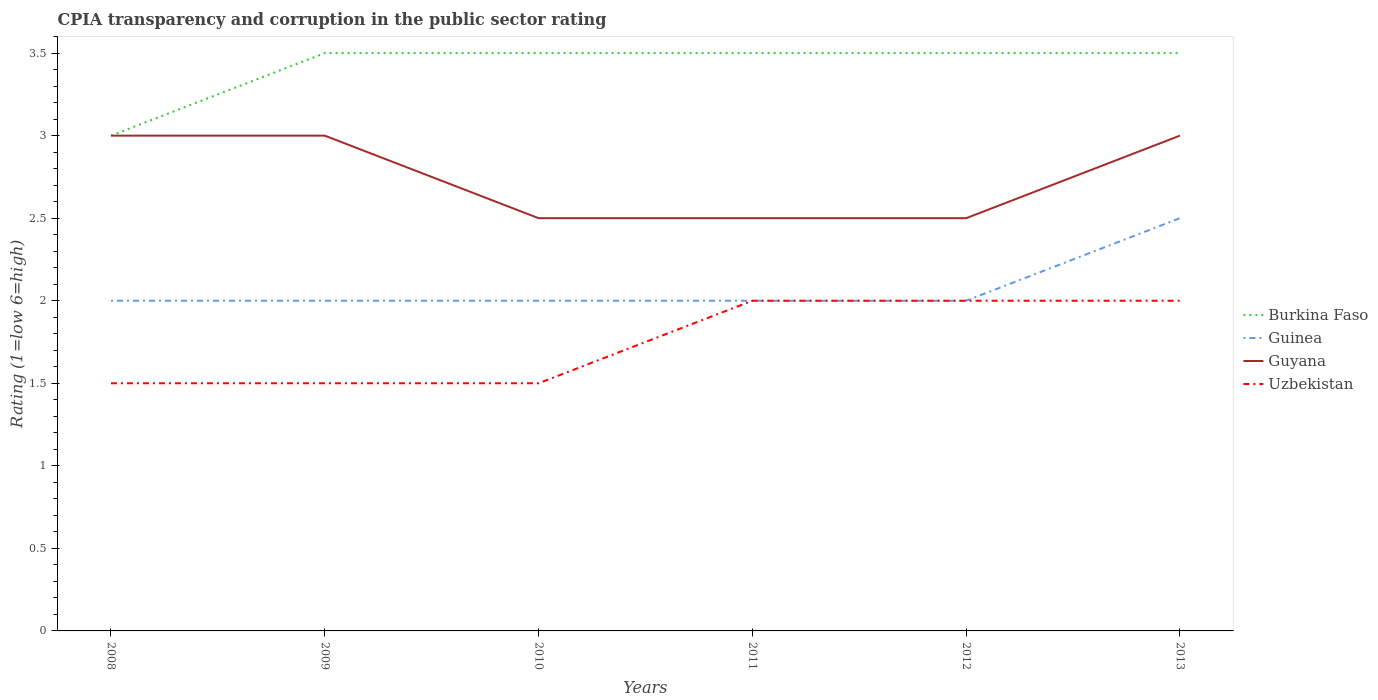Does the line corresponding to Guyana intersect with the line corresponding to Uzbekistan?
Offer a terse response. No. Is the number of lines equal to the number of legend labels?
Offer a very short reply. Yes. In which year was the CPIA rating in Uzbekistan maximum?
Provide a succinct answer. 2008. What is the total CPIA rating in Guinea in the graph?
Your response must be concise. -0.5. Is the CPIA rating in Burkina Faso strictly greater than the CPIA rating in Uzbekistan over the years?
Provide a succinct answer. No. What is the difference between two consecutive major ticks on the Y-axis?
Your answer should be compact. 0.5. Does the graph contain any zero values?
Offer a terse response. No. Does the graph contain grids?
Provide a succinct answer. No. Where does the legend appear in the graph?
Your answer should be very brief. Center right. How are the legend labels stacked?
Provide a succinct answer. Vertical. What is the title of the graph?
Your answer should be very brief. CPIA transparency and corruption in the public sector rating. What is the label or title of the X-axis?
Ensure brevity in your answer.  Years. What is the Rating (1=low 6=high) in Guinea in 2008?
Your response must be concise. 2. What is the Rating (1=low 6=high) of Guyana in 2008?
Your answer should be very brief. 3. What is the Rating (1=low 6=high) in Burkina Faso in 2009?
Your answer should be compact. 3.5. What is the Rating (1=low 6=high) in Guinea in 2009?
Provide a short and direct response. 2. What is the Rating (1=low 6=high) of Uzbekistan in 2009?
Provide a succinct answer. 1.5. What is the Rating (1=low 6=high) in Guinea in 2010?
Offer a very short reply. 2. What is the Rating (1=low 6=high) of Guyana in 2010?
Your answer should be compact. 2.5. What is the Rating (1=low 6=high) of Uzbekistan in 2010?
Your answer should be compact. 1.5. What is the Rating (1=low 6=high) of Guinea in 2011?
Your response must be concise. 2. Across all years, what is the maximum Rating (1=low 6=high) in Burkina Faso?
Your response must be concise. 3.5. Across all years, what is the maximum Rating (1=low 6=high) of Guinea?
Keep it short and to the point. 2.5. Across all years, what is the maximum Rating (1=low 6=high) in Uzbekistan?
Your answer should be compact. 2. Across all years, what is the minimum Rating (1=low 6=high) in Burkina Faso?
Offer a very short reply. 3. Across all years, what is the minimum Rating (1=low 6=high) of Guinea?
Provide a succinct answer. 2. What is the total Rating (1=low 6=high) of Burkina Faso in the graph?
Your answer should be very brief. 20.5. What is the total Rating (1=low 6=high) in Uzbekistan in the graph?
Provide a succinct answer. 10.5. What is the difference between the Rating (1=low 6=high) of Burkina Faso in 2008 and that in 2009?
Your answer should be very brief. -0.5. What is the difference between the Rating (1=low 6=high) of Guyana in 2008 and that in 2009?
Ensure brevity in your answer.  0. What is the difference between the Rating (1=low 6=high) of Uzbekistan in 2008 and that in 2009?
Offer a terse response. 0. What is the difference between the Rating (1=low 6=high) of Burkina Faso in 2008 and that in 2010?
Keep it short and to the point. -0.5. What is the difference between the Rating (1=low 6=high) in Guyana in 2008 and that in 2010?
Offer a very short reply. 0.5. What is the difference between the Rating (1=low 6=high) of Uzbekistan in 2008 and that in 2010?
Provide a short and direct response. 0. What is the difference between the Rating (1=low 6=high) in Burkina Faso in 2008 and that in 2011?
Provide a short and direct response. -0.5. What is the difference between the Rating (1=low 6=high) of Guinea in 2008 and that in 2011?
Your response must be concise. 0. What is the difference between the Rating (1=low 6=high) in Guyana in 2008 and that in 2011?
Offer a terse response. 0.5. What is the difference between the Rating (1=low 6=high) in Uzbekistan in 2008 and that in 2011?
Offer a terse response. -0.5. What is the difference between the Rating (1=low 6=high) in Burkina Faso in 2008 and that in 2012?
Offer a terse response. -0.5. What is the difference between the Rating (1=low 6=high) of Burkina Faso in 2008 and that in 2013?
Ensure brevity in your answer.  -0.5. What is the difference between the Rating (1=low 6=high) in Guyana in 2008 and that in 2013?
Give a very brief answer. 0. What is the difference between the Rating (1=low 6=high) of Guyana in 2009 and that in 2011?
Offer a terse response. 0.5. What is the difference between the Rating (1=low 6=high) in Burkina Faso in 2009 and that in 2012?
Offer a terse response. 0. What is the difference between the Rating (1=low 6=high) of Burkina Faso in 2009 and that in 2013?
Provide a short and direct response. 0. What is the difference between the Rating (1=low 6=high) in Guinea in 2009 and that in 2013?
Ensure brevity in your answer.  -0.5. What is the difference between the Rating (1=low 6=high) in Uzbekistan in 2009 and that in 2013?
Provide a succinct answer. -0.5. What is the difference between the Rating (1=low 6=high) of Burkina Faso in 2010 and that in 2011?
Your answer should be very brief. 0. What is the difference between the Rating (1=low 6=high) in Guinea in 2010 and that in 2011?
Give a very brief answer. 0. What is the difference between the Rating (1=low 6=high) in Burkina Faso in 2010 and that in 2012?
Provide a short and direct response. 0. What is the difference between the Rating (1=low 6=high) in Guinea in 2010 and that in 2012?
Provide a short and direct response. 0. What is the difference between the Rating (1=low 6=high) in Guyana in 2010 and that in 2012?
Provide a short and direct response. 0. What is the difference between the Rating (1=low 6=high) of Uzbekistan in 2010 and that in 2012?
Offer a very short reply. -0.5. What is the difference between the Rating (1=low 6=high) of Guinea in 2010 and that in 2013?
Your answer should be compact. -0.5. What is the difference between the Rating (1=low 6=high) of Guyana in 2010 and that in 2013?
Ensure brevity in your answer.  -0.5. What is the difference between the Rating (1=low 6=high) of Guinea in 2011 and that in 2012?
Give a very brief answer. 0. What is the difference between the Rating (1=low 6=high) of Burkina Faso in 2011 and that in 2013?
Your answer should be very brief. 0. What is the difference between the Rating (1=low 6=high) of Burkina Faso in 2012 and that in 2013?
Offer a very short reply. 0. What is the difference between the Rating (1=low 6=high) in Guinea in 2012 and that in 2013?
Offer a very short reply. -0.5. What is the difference between the Rating (1=low 6=high) of Guyana in 2012 and that in 2013?
Offer a terse response. -0.5. What is the difference between the Rating (1=low 6=high) in Uzbekistan in 2012 and that in 2013?
Offer a very short reply. 0. What is the difference between the Rating (1=low 6=high) in Burkina Faso in 2008 and the Rating (1=low 6=high) in Guinea in 2009?
Provide a short and direct response. 1. What is the difference between the Rating (1=low 6=high) of Burkina Faso in 2008 and the Rating (1=low 6=high) of Guyana in 2009?
Keep it short and to the point. 0. What is the difference between the Rating (1=low 6=high) of Guinea in 2008 and the Rating (1=low 6=high) of Uzbekistan in 2009?
Offer a very short reply. 0.5. What is the difference between the Rating (1=low 6=high) in Burkina Faso in 2008 and the Rating (1=low 6=high) in Guinea in 2010?
Your answer should be very brief. 1. What is the difference between the Rating (1=low 6=high) of Burkina Faso in 2008 and the Rating (1=low 6=high) of Uzbekistan in 2010?
Offer a very short reply. 1.5. What is the difference between the Rating (1=low 6=high) of Guyana in 2008 and the Rating (1=low 6=high) of Uzbekistan in 2010?
Make the answer very short. 1.5. What is the difference between the Rating (1=low 6=high) in Burkina Faso in 2008 and the Rating (1=low 6=high) in Guyana in 2011?
Offer a terse response. 0.5. What is the difference between the Rating (1=low 6=high) in Burkina Faso in 2008 and the Rating (1=low 6=high) in Uzbekistan in 2011?
Provide a succinct answer. 1. What is the difference between the Rating (1=low 6=high) of Guinea in 2008 and the Rating (1=low 6=high) of Guyana in 2011?
Provide a short and direct response. -0.5. What is the difference between the Rating (1=low 6=high) in Guinea in 2008 and the Rating (1=low 6=high) in Uzbekistan in 2011?
Keep it short and to the point. 0. What is the difference between the Rating (1=low 6=high) in Burkina Faso in 2008 and the Rating (1=low 6=high) in Guinea in 2012?
Give a very brief answer. 1. What is the difference between the Rating (1=low 6=high) in Burkina Faso in 2008 and the Rating (1=low 6=high) in Guyana in 2012?
Offer a terse response. 0.5. What is the difference between the Rating (1=low 6=high) of Burkina Faso in 2008 and the Rating (1=low 6=high) of Uzbekistan in 2012?
Ensure brevity in your answer.  1. What is the difference between the Rating (1=low 6=high) of Guinea in 2008 and the Rating (1=low 6=high) of Guyana in 2012?
Make the answer very short. -0.5. What is the difference between the Rating (1=low 6=high) of Guinea in 2008 and the Rating (1=low 6=high) of Uzbekistan in 2012?
Your answer should be very brief. 0. What is the difference between the Rating (1=low 6=high) of Guyana in 2008 and the Rating (1=low 6=high) of Uzbekistan in 2012?
Your response must be concise. 1. What is the difference between the Rating (1=low 6=high) of Burkina Faso in 2008 and the Rating (1=low 6=high) of Guyana in 2013?
Your answer should be compact. 0. What is the difference between the Rating (1=low 6=high) in Guyana in 2008 and the Rating (1=low 6=high) in Uzbekistan in 2013?
Provide a short and direct response. 1. What is the difference between the Rating (1=low 6=high) of Guinea in 2009 and the Rating (1=low 6=high) of Uzbekistan in 2010?
Give a very brief answer. 0.5. What is the difference between the Rating (1=low 6=high) in Guyana in 2009 and the Rating (1=low 6=high) in Uzbekistan in 2010?
Your answer should be compact. 1.5. What is the difference between the Rating (1=low 6=high) in Burkina Faso in 2009 and the Rating (1=low 6=high) in Guinea in 2011?
Keep it short and to the point. 1.5. What is the difference between the Rating (1=low 6=high) of Burkina Faso in 2009 and the Rating (1=low 6=high) of Guyana in 2011?
Ensure brevity in your answer.  1. What is the difference between the Rating (1=low 6=high) in Guinea in 2009 and the Rating (1=low 6=high) in Uzbekistan in 2011?
Provide a succinct answer. 0. What is the difference between the Rating (1=low 6=high) in Guyana in 2009 and the Rating (1=low 6=high) in Uzbekistan in 2011?
Ensure brevity in your answer.  1. What is the difference between the Rating (1=low 6=high) in Burkina Faso in 2009 and the Rating (1=low 6=high) in Guinea in 2012?
Your response must be concise. 1.5. What is the difference between the Rating (1=low 6=high) in Burkina Faso in 2009 and the Rating (1=low 6=high) in Uzbekistan in 2012?
Provide a short and direct response. 1.5. What is the difference between the Rating (1=low 6=high) of Guyana in 2009 and the Rating (1=low 6=high) of Uzbekistan in 2012?
Ensure brevity in your answer.  1. What is the difference between the Rating (1=low 6=high) of Burkina Faso in 2009 and the Rating (1=low 6=high) of Uzbekistan in 2013?
Ensure brevity in your answer.  1.5. What is the difference between the Rating (1=low 6=high) of Guyana in 2009 and the Rating (1=low 6=high) of Uzbekistan in 2013?
Your response must be concise. 1. What is the difference between the Rating (1=low 6=high) of Guinea in 2010 and the Rating (1=low 6=high) of Guyana in 2011?
Ensure brevity in your answer.  -0.5. What is the difference between the Rating (1=low 6=high) in Guinea in 2010 and the Rating (1=low 6=high) in Uzbekistan in 2011?
Offer a terse response. 0. What is the difference between the Rating (1=low 6=high) of Guyana in 2010 and the Rating (1=low 6=high) of Uzbekistan in 2011?
Offer a terse response. 0.5. What is the difference between the Rating (1=low 6=high) of Burkina Faso in 2010 and the Rating (1=low 6=high) of Guinea in 2012?
Your answer should be compact. 1.5. What is the difference between the Rating (1=low 6=high) in Burkina Faso in 2010 and the Rating (1=low 6=high) in Guyana in 2012?
Your response must be concise. 1. What is the difference between the Rating (1=low 6=high) in Guinea in 2010 and the Rating (1=low 6=high) in Guyana in 2012?
Your answer should be very brief. -0.5. What is the difference between the Rating (1=low 6=high) in Guinea in 2010 and the Rating (1=low 6=high) in Uzbekistan in 2012?
Your answer should be very brief. 0. What is the difference between the Rating (1=low 6=high) in Guyana in 2010 and the Rating (1=low 6=high) in Uzbekistan in 2012?
Your answer should be very brief. 0.5. What is the difference between the Rating (1=low 6=high) in Guinea in 2010 and the Rating (1=low 6=high) in Guyana in 2013?
Ensure brevity in your answer.  -1. What is the difference between the Rating (1=low 6=high) of Burkina Faso in 2011 and the Rating (1=low 6=high) of Guyana in 2012?
Your answer should be compact. 1. What is the difference between the Rating (1=low 6=high) in Burkina Faso in 2011 and the Rating (1=low 6=high) in Uzbekistan in 2012?
Give a very brief answer. 1.5. What is the difference between the Rating (1=low 6=high) of Guinea in 2011 and the Rating (1=low 6=high) of Uzbekistan in 2012?
Keep it short and to the point. 0. What is the difference between the Rating (1=low 6=high) of Burkina Faso in 2011 and the Rating (1=low 6=high) of Guinea in 2013?
Offer a very short reply. 1. What is the difference between the Rating (1=low 6=high) of Burkina Faso in 2011 and the Rating (1=low 6=high) of Guyana in 2013?
Ensure brevity in your answer.  0.5. What is the difference between the Rating (1=low 6=high) of Guinea in 2011 and the Rating (1=low 6=high) of Uzbekistan in 2013?
Your answer should be compact. 0. What is the difference between the Rating (1=low 6=high) in Burkina Faso in 2012 and the Rating (1=low 6=high) in Guinea in 2013?
Your response must be concise. 1. What is the difference between the Rating (1=low 6=high) of Guinea in 2012 and the Rating (1=low 6=high) of Uzbekistan in 2013?
Give a very brief answer. 0. What is the average Rating (1=low 6=high) of Burkina Faso per year?
Keep it short and to the point. 3.42. What is the average Rating (1=low 6=high) of Guinea per year?
Give a very brief answer. 2.08. What is the average Rating (1=low 6=high) of Guyana per year?
Offer a very short reply. 2.75. In the year 2008, what is the difference between the Rating (1=low 6=high) of Burkina Faso and Rating (1=low 6=high) of Guyana?
Your answer should be very brief. 0. In the year 2008, what is the difference between the Rating (1=low 6=high) of Burkina Faso and Rating (1=low 6=high) of Uzbekistan?
Provide a short and direct response. 1.5. In the year 2008, what is the difference between the Rating (1=low 6=high) of Guinea and Rating (1=low 6=high) of Guyana?
Your answer should be very brief. -1. In the year 2008, what is the difference between the Rating (1=low 6=high) of Guyana and Rating (1=low 6=high) of Uzbekistan?
Give a very brief answer. 1.5. In the year 2009, what is the difference between the Rating (1=low 6=high) of Burkina Faso and Rating (1=low 6=high) of Guinea?
Your answer should be very brief. 1.5. In the year 2009, what is the difference between the Rating (1=low 6=high) in Guinea and Rating (1=low 6=high) in Uzbekistan?
Your response must be concise. 0.5. In the year 2009, what is the difference between the Rating (1=low 6=high) of Guyana and Rating (1=low 6=high) of Uzbekistan?
Offer a very short reply. 1.5. In the year 2010, what is the difference between the Rating (1=low 6=high) in Burkina Faso and Rating (1=low 6=high) in Guinea?
Offer a very short reply. 1.5. In the year 2010, what is the difference between the Rating (1=low 6=high) of Burkina Faso and Rating (1=low 6=high) of Guyana?
Provide a succinct answer. 1. In the year 2010, what is the difference between the Rating (1=low 6=high) in Guinea and Rating (1=low 6=high) in Guyana?
Provide a succinct answer. -0.5. In the year 2010, what is the difference between the Rating (1=low 6=high) of Guinea and Rating (1=low 6=high) of Uzbekistan?
Give a very brief answer. 0.5. In the year 2010, what is the difference between the Rating (1=low 6=high) of Guyana and Rating (1=low 6=high) of Uzbekistan?
Give a very brief answer. 1. In the year 2011, what is the difference between the Rating (1=low 6=high) in Burkina Faso and Rating (1=low 6=high) in Guinea?
Make the answer very short. 1.5. In the year 2012, what is the difference between the Rating (1=low 6=high) in Burkina Faso and Rating (1=low 6=high) in Guyana?
Offer a terse response. 1. In the year 2012, what is the difference between the Rating (1=low 6=high) of Guinea and Rating (1=low 6=high) of Guyana?
Your answer should be compact. -0.5. In the year 2013, what is the difference between the Rating (1=low 6=high) in Burkina Faso and Rating (1=low 6=high) in Guinea?
Your answer should be compact. 1. In the year 2013, what is the difference between the Rating (1=low 6=high) of Guinea and Rating (1=low 6=high) of Guyana?
Ensure brevity in your answer.  -0.5. In the year 2013, what is the difference between the Rating (1=low 6=high) in Guinea and Rating (1=low 6=high) in Uzbekistan?
Your answer should be very brief. 0.5. What is the ratio of the Rating (1=low 6=high) in Burkina Faso in 2008 to that in 2009?
Your response must be concise. 0.86. What is the ratio of the Rating (1=low 6=high) in Guyana in 2008 to that in 2009?
Ensure brevity in your answer.  1. What is the ratio of the Rating (1=low 6=high) in Uzbekistan in 2008 to that in 2009?
Your answer should be compact. 1. What is the ratio of the Rating (1=low 6=high) in Guinea in 2008 to that in 2010?
Give a very brief answer. 1. What is the ratio of the Rating (1=low 6=high) in Guyana in 2008 to that in 2010?
Your answer should be compact. 1.2. What is the ratio of the Rating (1=low 6=high) in Guyana in 2008 to that in 2011?
Ensure brevity in your answer.  1.2. What is the ratio of the Rating (1=low 6=high) in Guinea in 2008 to that in 2012?
Your answer should be very brief. 1. What is the ratio of the Rating (1=low 6=high) of Uzbekistan in 2008 to that in 2012?
Ensure brevity in your answer.  0.75. What is the ratio of the Rating (1=low 6=high) of Uzbekistan in 2008 to that in 2013?
Make the answer very short. 0.75. What is the ratio of the Rating (1=low 6=high) in Burkina Faso in 2009 to that in 2011?
Offer a terse response. 1. What is the ratio of the Rating (1=low 6=high) of Guyana in 2009 to that in 2012?
Provide a succinct answer. 1.2. What is the ratio of the Rating (1=low 6=high) in Burkina Faso in 2010 to that in 2011?
Offer a terse response. 1. What is the ratio of the Rating (1=low 6=high) of Burkina Faso in 2010 to that in 2012?
Provide a short and direct response. 1. What is the ratio of the Rating (1=low 6=high) of Guinea in 2010 to that in 2013?
Offer a very short reply. 0.8. What is the ratio of the Rating (1=low 6=high) of Guyana in 2010 to that in 2013?
Your answer should be compact. 0.83. What is the ratio of the Rating (1=low 6=high) of Guyana in 2011 to that in 2012?
Your response must be concise. 1. What is the ratio of the Rating (1=low 6=high) in Uzbekistan in 2011 to that in 2012?
Your answer should be compact. 1. What is the ratio of the Rating (1=low 6=high) in Guinea in 2011 to that in 2013?
Your response must be concise. 0.8. What is the ratio of the Rating (1=low 6=high) in Guyana in 2011 to that in 2013?
Give a very brief answer. 0.83. What is the ratio of the Rating (1=low 6=high) of Guinea in 2012 to that in 2013?
Keep it short and to the point. 0.8. What is the difference between the highest and the second highest Rating (1=low 6=high) in Guinea?
Your response must be concise. 0.5. What is the difference between the highest and the second highest Rating (1=low 6=high) in Guyana?
Make the answer very short. 0. What is the difference between the highest and the lowest Rating (1=low 6=high) in Burkina Faso?
Offer a very short reply. 0.5. What is the difference between the highest and the lowest Rating (1=low 6=high) in Guinea?
Your answer should be compact. 0.5. What is the difference between the highest and the lowest Rating (1=low 6=high) of Guyana?
Provide a short and direct response. 0.5. What is the difference between the highest and the lowest Rating (1=low 6=high) of Uzbekistan?
Your answer should be compact. 0.5. 